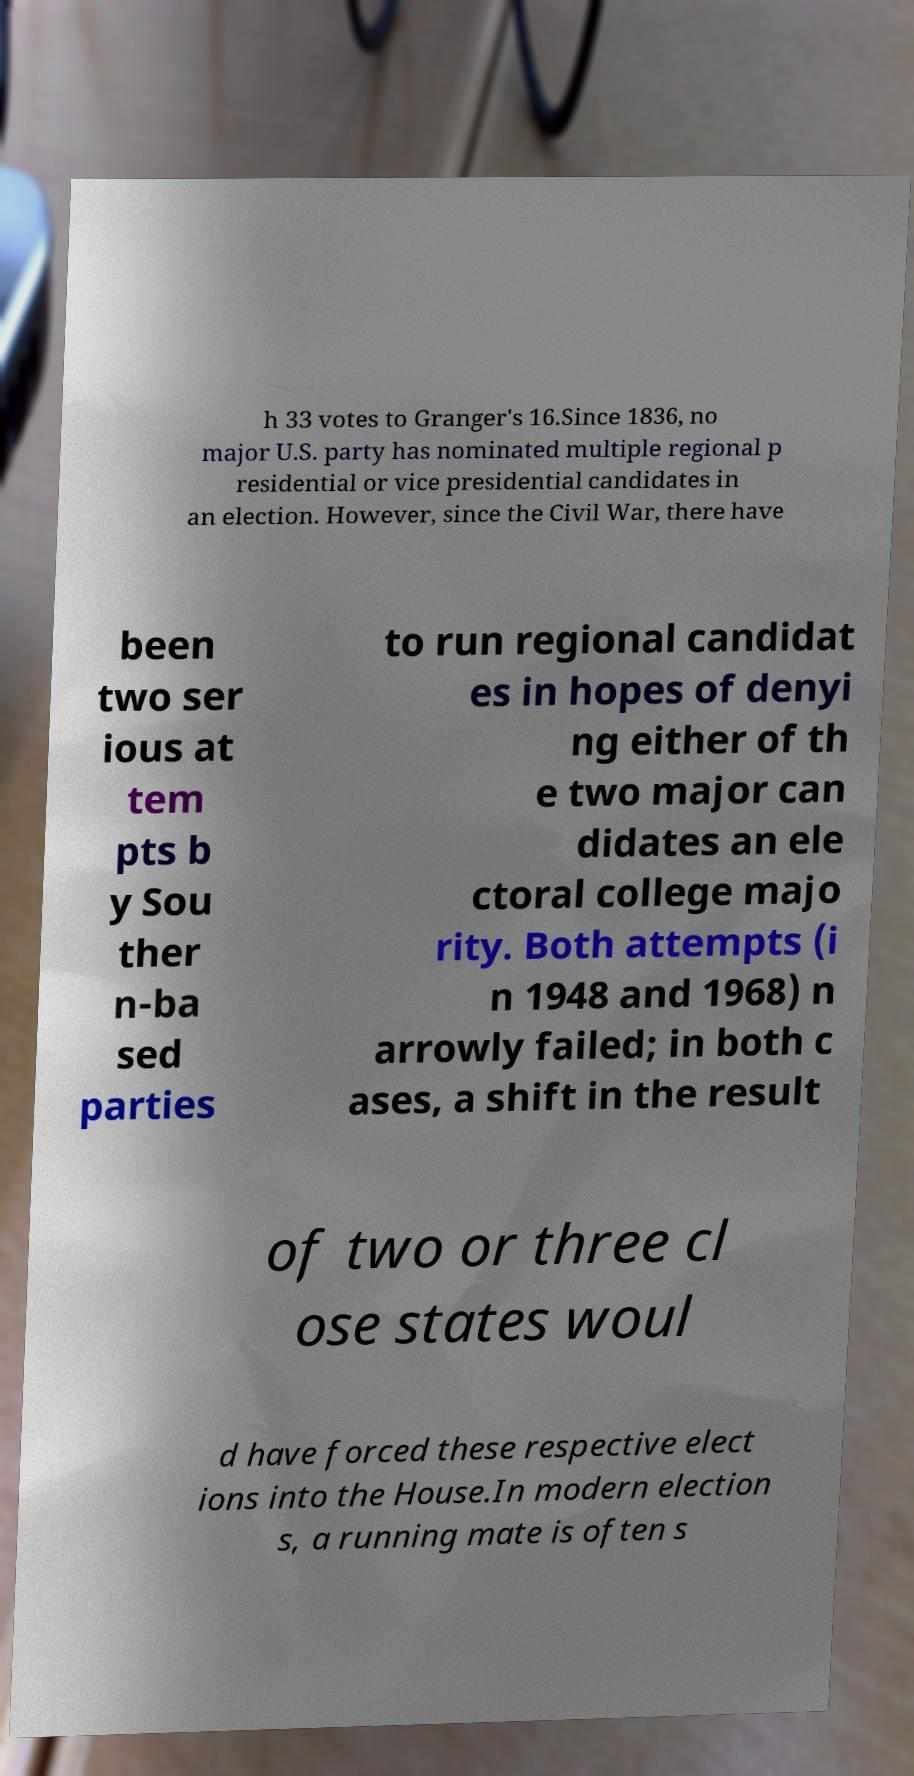What messages or text are displayed in this image? I need them in a readable, typed format. h 33 votes to Granger's 16.Since 1836, no major U.S. party has nominated multiple regional p residential or vice presidential candidates in an election. However, since the Civil War, there have been two ser ious at tem pts b y Sou ther n-ba sed parties to run regional candidat es in hopes of denyi ng either of th e two major can didates an ele ctoral college majo rity. Both attempts (i n 1948 and 1968) n arrowly failed; in both c ases, a shift in the result of two or three cl ose states woul d have forced these respective elect ions into the House.In modern election s, a running mate is often s 